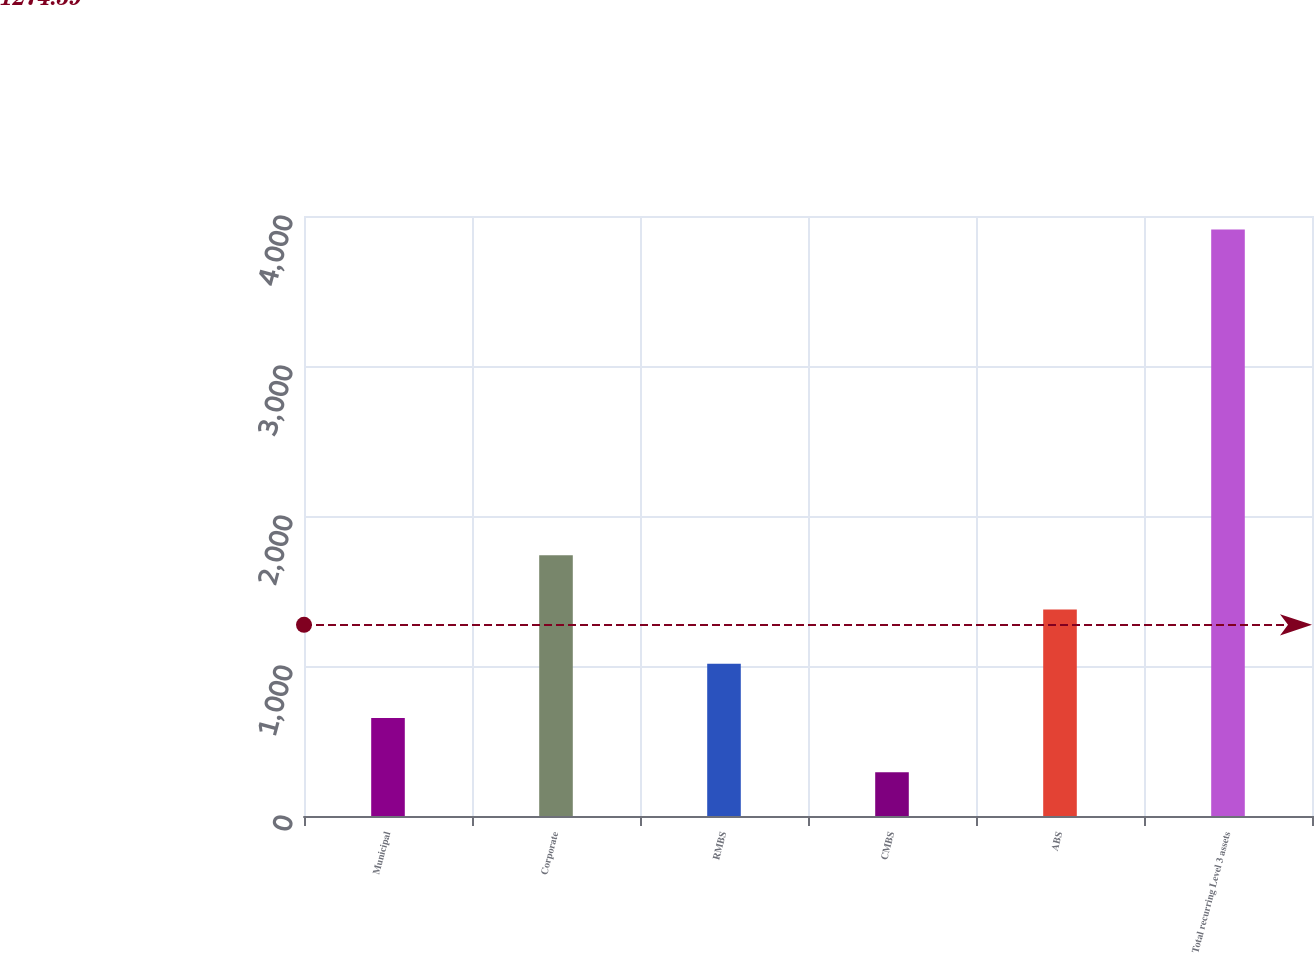<chart> <loc_0><loc_0><loc_500><loc_500><bar_chart><fcel>Municipal<fcel>Corporate<fcel>RMBS<fcel>CMBS<fcel>ABS<fcel>Total recurring Level 3 assets<nl><fcel>652.9<fcel>1738.6<fcel>1014.8<fcel>291<fcel>1376.7<fcel>3910<nl></chart> 